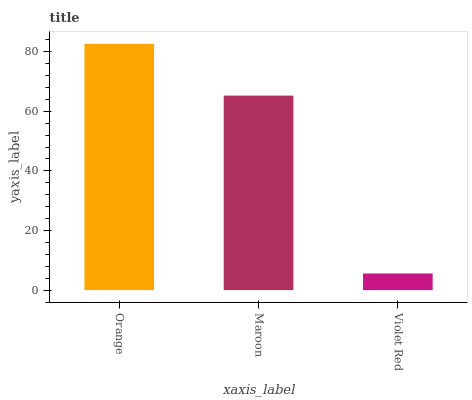Is Violet Red the minimum?
Answer yes or no. Yes. Is Orange the maximum?
Answer yes or no. Yes. Is Maroon the minimum?
Answer yes or no. No. Is Maroon the maximum?
Answer yes or no. No. Is Orange greater than Maroon?
Answer yes or no. Yes. Is Maroon less than Orange?
Answer yes or no. Yes. Is Maroon greater than Orange?
Answer yes or no. No. Is Orange less than Maroon?
Answer yes or no. No. Is Maroon the high median?
Answer yes or no. Yes. Is Maroon the low median?
Answer yes or no. Yes. Is Violet Red the high median?
Answer yes or no. No. Is Violet Red the low median?
Answer yes or no. No. 